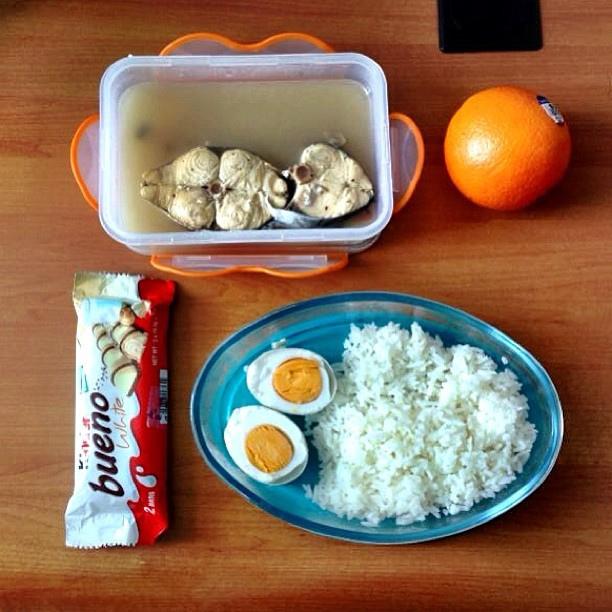What kind of fruit is in the top right corner?
Concise answer only. Orange. Is this food healthy?
Quick response, please. Yes. Is this breakfast or dinner?
Quick response, please. Breakfast. 